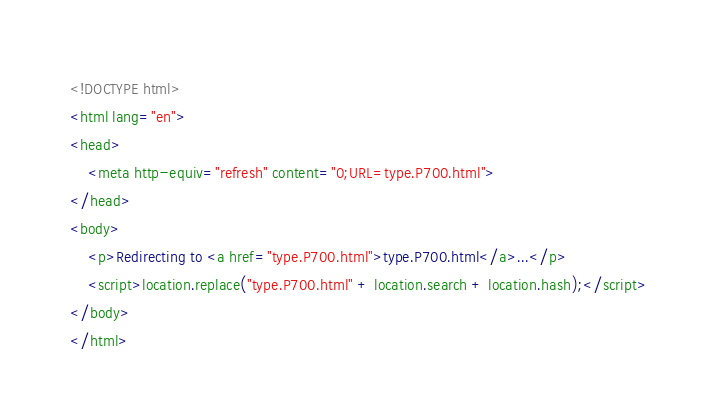Convert code to text. <code><loc_0><loc_0><loc_500><loc_500><_HTML_><!DOCTYPE html>
<html lang="en">
<head>
    <meta http-equiv="refresh" content="0;URL=type.P700.html">
</head>
<body>
    <p>Redirecting to <a href="type.P700.html">type.P700.html</a>...</p>
    <script>location.replace("type.P700.html" + location.search + location.hash);</script>
</body>
</html></code> 